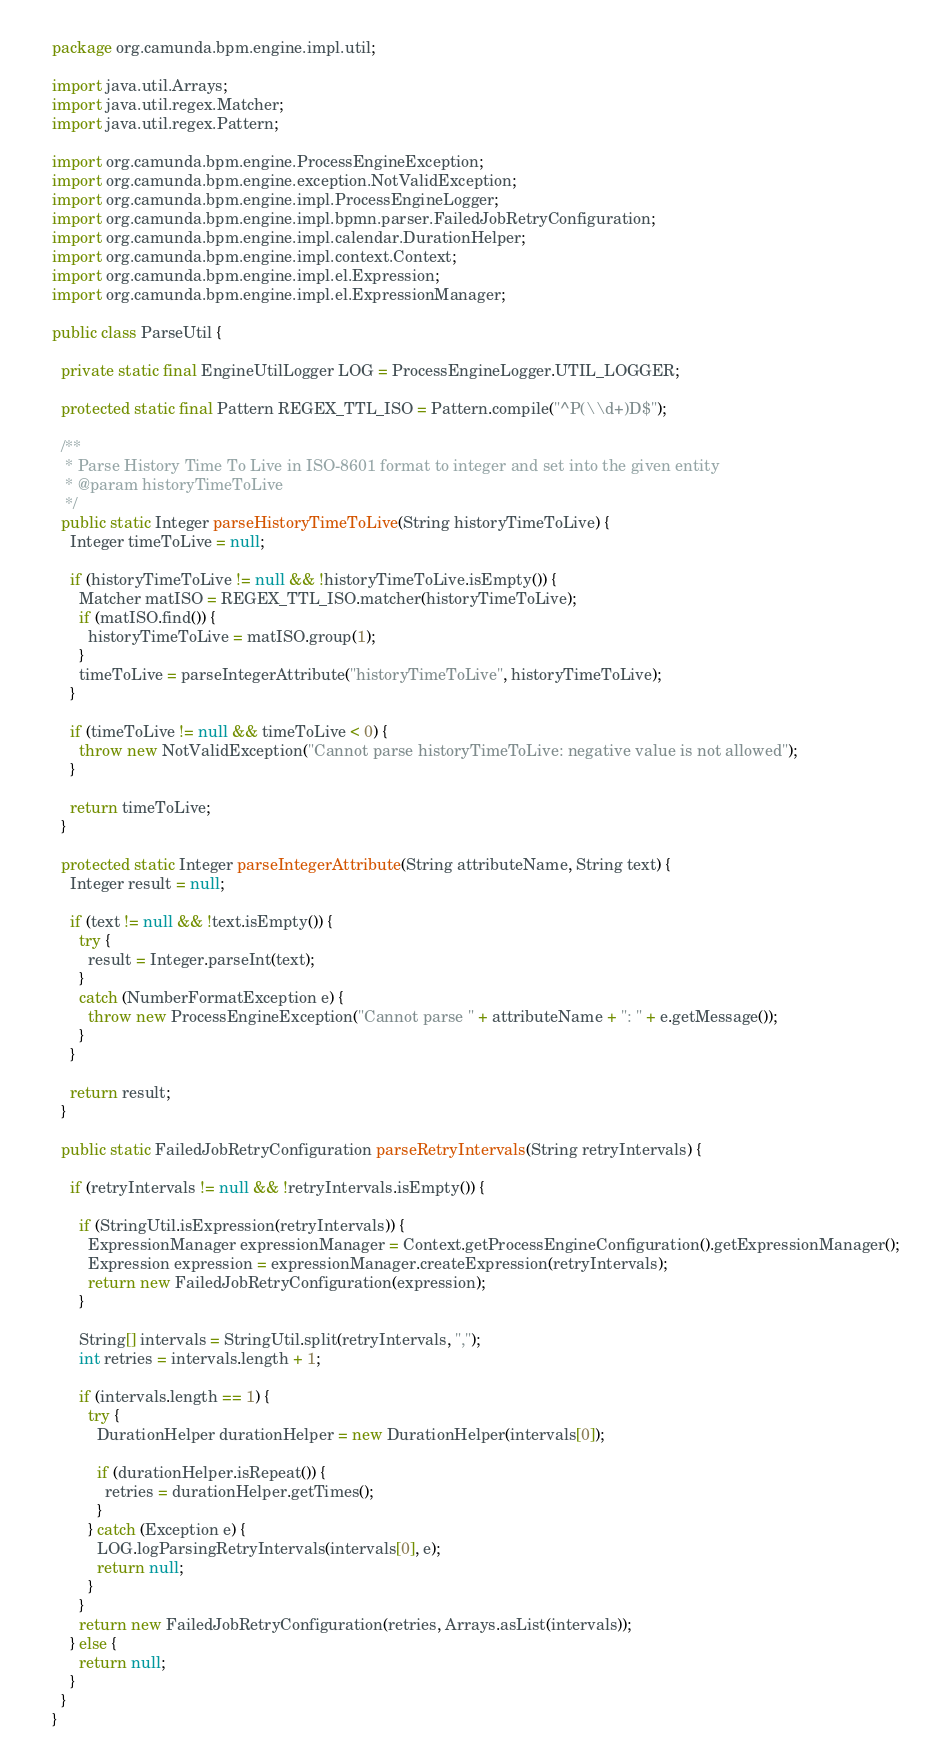<code> <loc_0><loc_0><loc_500><loc_500><_Java_>package org.camunda.bpm.engine.impl.util;

import java.util.Arrays;
import java.util.regex.Matcher;
import java.util.regex.Pattern;

import org.camunda.bpm.engine.ProcessEngineException;
import org.camunda.bpm.engine.exception.NotValidException;
import org.camunda.bpm.engine.impl.ProcessEngineLogger;
import org.camunda.bpm.engine.impl.bpmn.parser.FailedJobRetryConfiguration;
import org.camunda.bpm.engine.impl.calendar.DurationHelper;
import org.camunda.bpm.engine.impl.context.Context;
import org.camunda.bpm.engine.impl.el.Expression;
import org.camunda.bpm.engine.impl.el.ExpressionManager;

public class ParseUtil {

  private static final EngineUtilLogger LOG = ProcessEngineLogger.UTIL_LOGGER;

  protected static final Pattern REGEX_TTL_ISO = Pattern.compile("^P(\\d+)D$");

  /**
   * Parse History Time To Live in ISO-8601 format to integer and set into the given entity
   * @param historyTimeToLive
   */
  public static Integer parseHistoryTimeToLive(String historyTimeToLive) {
    Integer timeToLive = null;

    if (historyTimeToLive != null && !historyTimeToLive.isEmpty()) {
      Matcher matISO = REGEX_TTL_ISO.matcher(historyTimeToLive);
      if (matISO.find()) {
        historyTimeToLive = matISO.group(1);
      }
      timeToLive = parseIntegerAttribute("historyTimeToLive", historyTimeToLive);
    }

    if (timeToLive != null && timeToLive < 0) {
      throw new NotValidException("Cannot parse historyTimeToLive: negative value is not allowed");
    }

    return timeToLive;
  }

  protected static Integer parseIntegerAttribute(String attributeName, String text) {
    Integer result = null;

    if (text != null && !text.isEmpty()) {
      try {
        result = Integer.parseInt(text);
      }
      catch (NumberFormatException e) {
        throw new ProcessEngineException("Cannot parse " + attributeName + ": " + e.getMessage());
      }
    }

    return result;
  }

  public static FailedJobRetryConfiguration parseRetryIntervals(String retryIntervals) {

    if (retryIntervals != null && !retryIntervals.isEmpty()) {

      if (StringUtil.isExpression(retryIntervals)) {
        ExpressionManager expressionManager = Context.getProcessEngineConfiguration().getExpressionManager();
        Expression expression = expressionManager.createExpression(retryIntervals);
        return new FailedJobRetryConfiguration(expression);
      }

      String[] intervals = StringUtil.split(retryIntervals, ",");
      int retries = intervals.length + 1;

      if (intervals.length == 1) {
        try {
          DurationHelper durationHelper = new DurationHelper(intervals[0]);

          if (durationHelper.isRepeat()) {
            retries = durationHelper.getTimes();
          }
        } catch (Exception e) {
          LOG.logParsingRetryIntervals(intervals[0], e);
          return null;
        }
      }
      return new FailedJobRetryConfiguration(retries, Arrays.asList(intervals));
    } else {
      return null;
    }
  }
}
</code> 